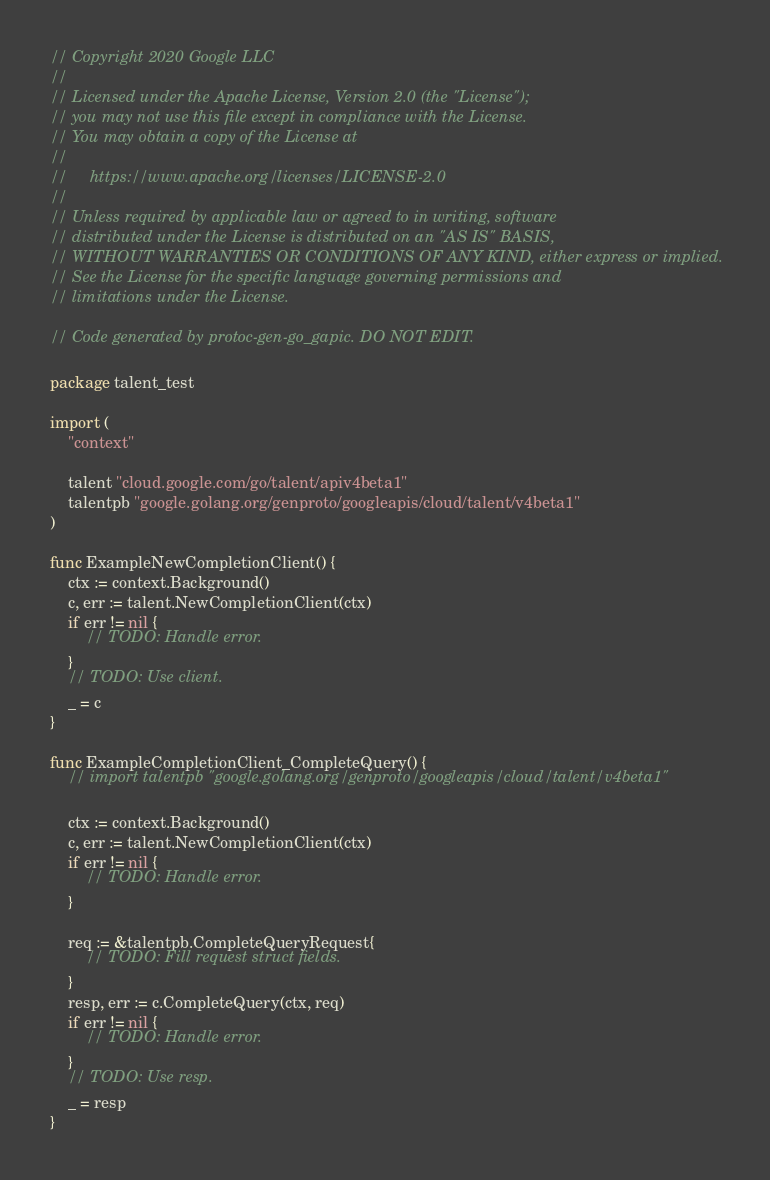Convert code to text. <code><loc_0><loc_0><loc_500><loc_500><_Go_>// Copyright 2020 Google LLC
//
// Licensed under the Apache License, Version 2.0 (the "License");
// you may not use this file except in compliance with the License.
// You may obtain a copy of the License at
//
//     https://www.apache.org/licenses/LICENSE-2.0
//
// Unless required by applicable law or agreed to in writing, software
// distributed under the License is distributed on an "AS IS" BASIS,
// WITHOUT WARRANTIES OR CONDITIONS OF ANY KIND, either express or implied.
// See the License for the specific language governing permissions and
// limitations under the License.

// Code generated by protoc-gen-go_gapic. DO NOT EDIT.

package talent_test

import (
	"context"

	talent "cloud.google.com/go/talent/apiv4beta1"
	talentpb "google.golang.org/genproto/googleapis/cloud/talent/v4beta1"
)

func ExampleNewCompletionClient() {
	ctx := context.Background()
	c, err := talent.NewCompletionClient(ctx)
	if err != nil {
		// TODO: Handle error.
	}
	// TODO: Use client.
	_ = c
}

func ExampleCompletionClient_CompleteQuery() {
	// import talentpb "google.golang.org/genproto/googleapis/cloud/talent/v4beta1"

	ctx := context.Background()
	c, err := talent.NewCompletionClient(ctx)
	if err != nil {
		// TODO: Handle error.
	}

	req := &talentpb.CompleteQueryRequest{
		// TODO: Fill request struct fields.
	}
	resp, err := c.CompleteQuery(ctx, req)
	if err != nil {
		// TODO: Handle error.
	}
	// TODO: Use resp.
	_ = resp
}
</code> 